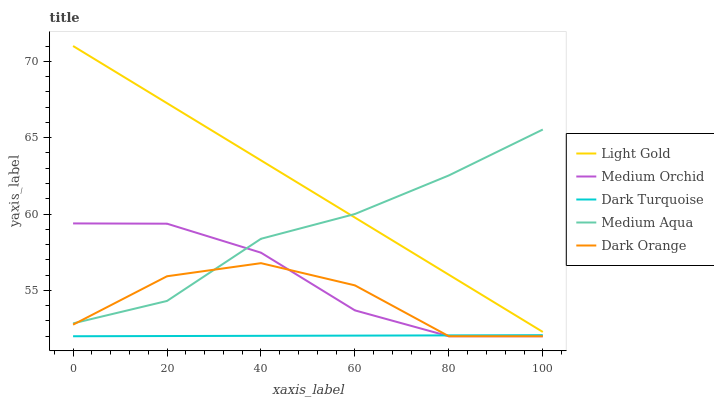Does Dark Turquoise have the minimum area under the curve?
Answer yes or no. Yes. Does Light Gold have the maximum area under the curve?
Answer yes or no. Yes. Does Medium Orchid have the minimum area under the curve?
Answer yes or no. No. Does Medium Orchid have the maximum area under the curve?
Answer yes or no. No. Is Light Gold the smoothest?
Answer yes or no. Yes. Is Dark Orange the roughest?
Answer yes or no. Yes. Is Dark Turquoise the smoothest?
Answer yes or no. No. Is Dark Turquoise the roughest?
Answer yes or no. No. Does Dark Turquoise have the lowest value?
Answer yes or no. Yes. Does Light Gold have the lowest value?
Answer yes or no. No. Does Light Gold have the highest value?
Answer yes or no. Yes. Does Medium Orchid have the highest value?
Answer yes or no. No. Is Dark Turquoise less than Light Gold?
Answer yes or no. Yes. Is Light Gold greater than Dark Orange?
Answer yes or no. Yes. Does Medium Orchid intersect Dark Turquoise?
Answer yes or no. Yes. Is Medium Orchid less than Dark Turquoise?
Answer yes or no. No. Is Medium Orchid greater than Dark Turquoise?
Answer yes or no. No. Does Dark Turquoise intersect Light Gold?
Answer yes or no. No. 